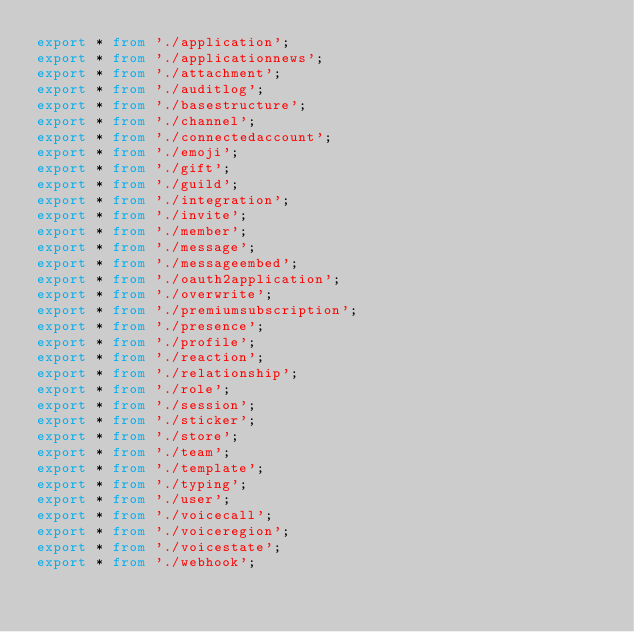<code> <loc_0><loc_0><loc_500><loc_500><_TypeScript_>export * from './application';
export * from './applicationnews';
export * from './attachment';
export * from './auditlog';
export * from './basestructure';
export * from './channel';
export * from './connectedaccount';
export * from './emoji';
export * from './gift';
export * from './guild';
export * from './integration';
export * from './invite';
export * from './member';
export * from './message';
export * from './messageembed';
export * from './oauth2application';
export * from './overwrite';
export * from './premiumsubscription';
export * from './presence';
export * from './profile';
export * from './reaction';
export * from './relationship';
export * from './role';
export * from './session';
export * from './sticker';
export * from './store';
export * from './team';
export * from './template';
export * from './typing';
export * from './user';
export * from './voicecall';
export * from './voiceregion';
export * from './voicestate';
export * from './webhook';
</code> 